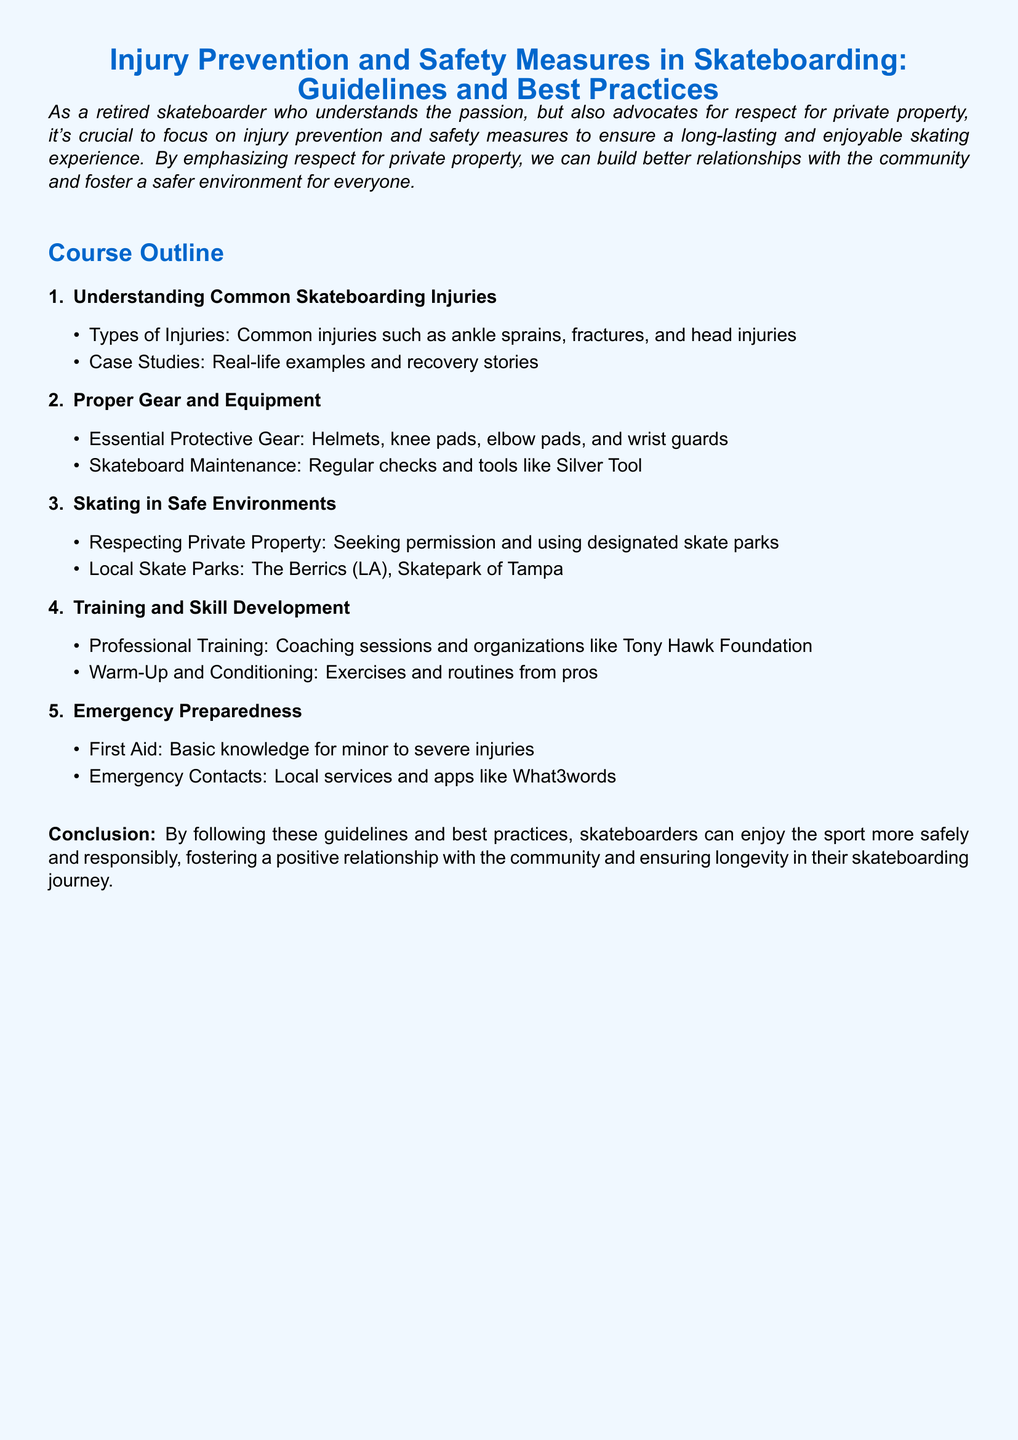What are common skateboard injuries? The document lists common injuries such as ankle sprains, fractures, and head injuries.
Answer: Ankle sprains, fractures, head injuries What essential protective gear is mentioned? The document refers to helmets, knee pads, elbow pads, and wrist guards as essential gear.
Answer: Helmets, knee pads, elbow pads, wrist guards Which skate park is mentioned in Los Angeles? The document specifically names The Berrics as a local skate park located in LA.
Answer: The Berrics What professional training organization is referenced? The Tony Hawk Foundation is mentioned in the context of professional training and coaching.
Answer: Tony Hawk Foundation What is emphasized regarding private property? The document highlights the importance of seeking permission and using designated skate parks.
Answer: Seeking permission, designated skate parks How many sections are in the course outline? The document outlines five key sections regarding injury prevention and safety measures in skateboarding.
Answer: Five What is essential knowledge for emergency preparedness? Basic knowledge for minor to severe injuries is outlined as essential first aid knowledge.
Answer: First Aid What tool is recommended for skateboard maintenance? The document mentions the Silver Tool as a recommended tool for skateboard maintenance.
Answer: Silver Tool What term is used for local emergency services? The document refers to apps like What3words as useful for emergency contacts.
Answer: What3words 